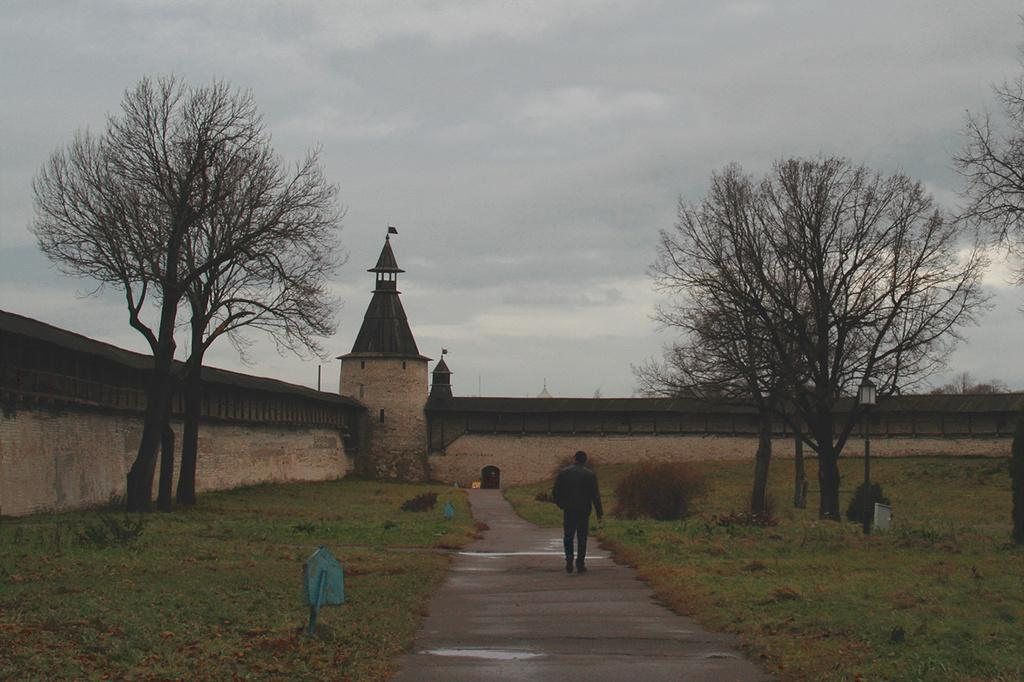What is the man in the image doing? The man in the image is walking on the road. What type of vegetation can be seen in the image? Grass, bushes, and trees are visible in the image. What type of structure is present in the image? There is a building in the image. What type of street furniture is present in the image? A street pole and a street light are present in the image. What is visible in the sky in the image? The sky is visible in the image, and clouds are present. What type of butter is being used to rub on the grandmother's back in the image? There is no grandmother or butter present in the image. 